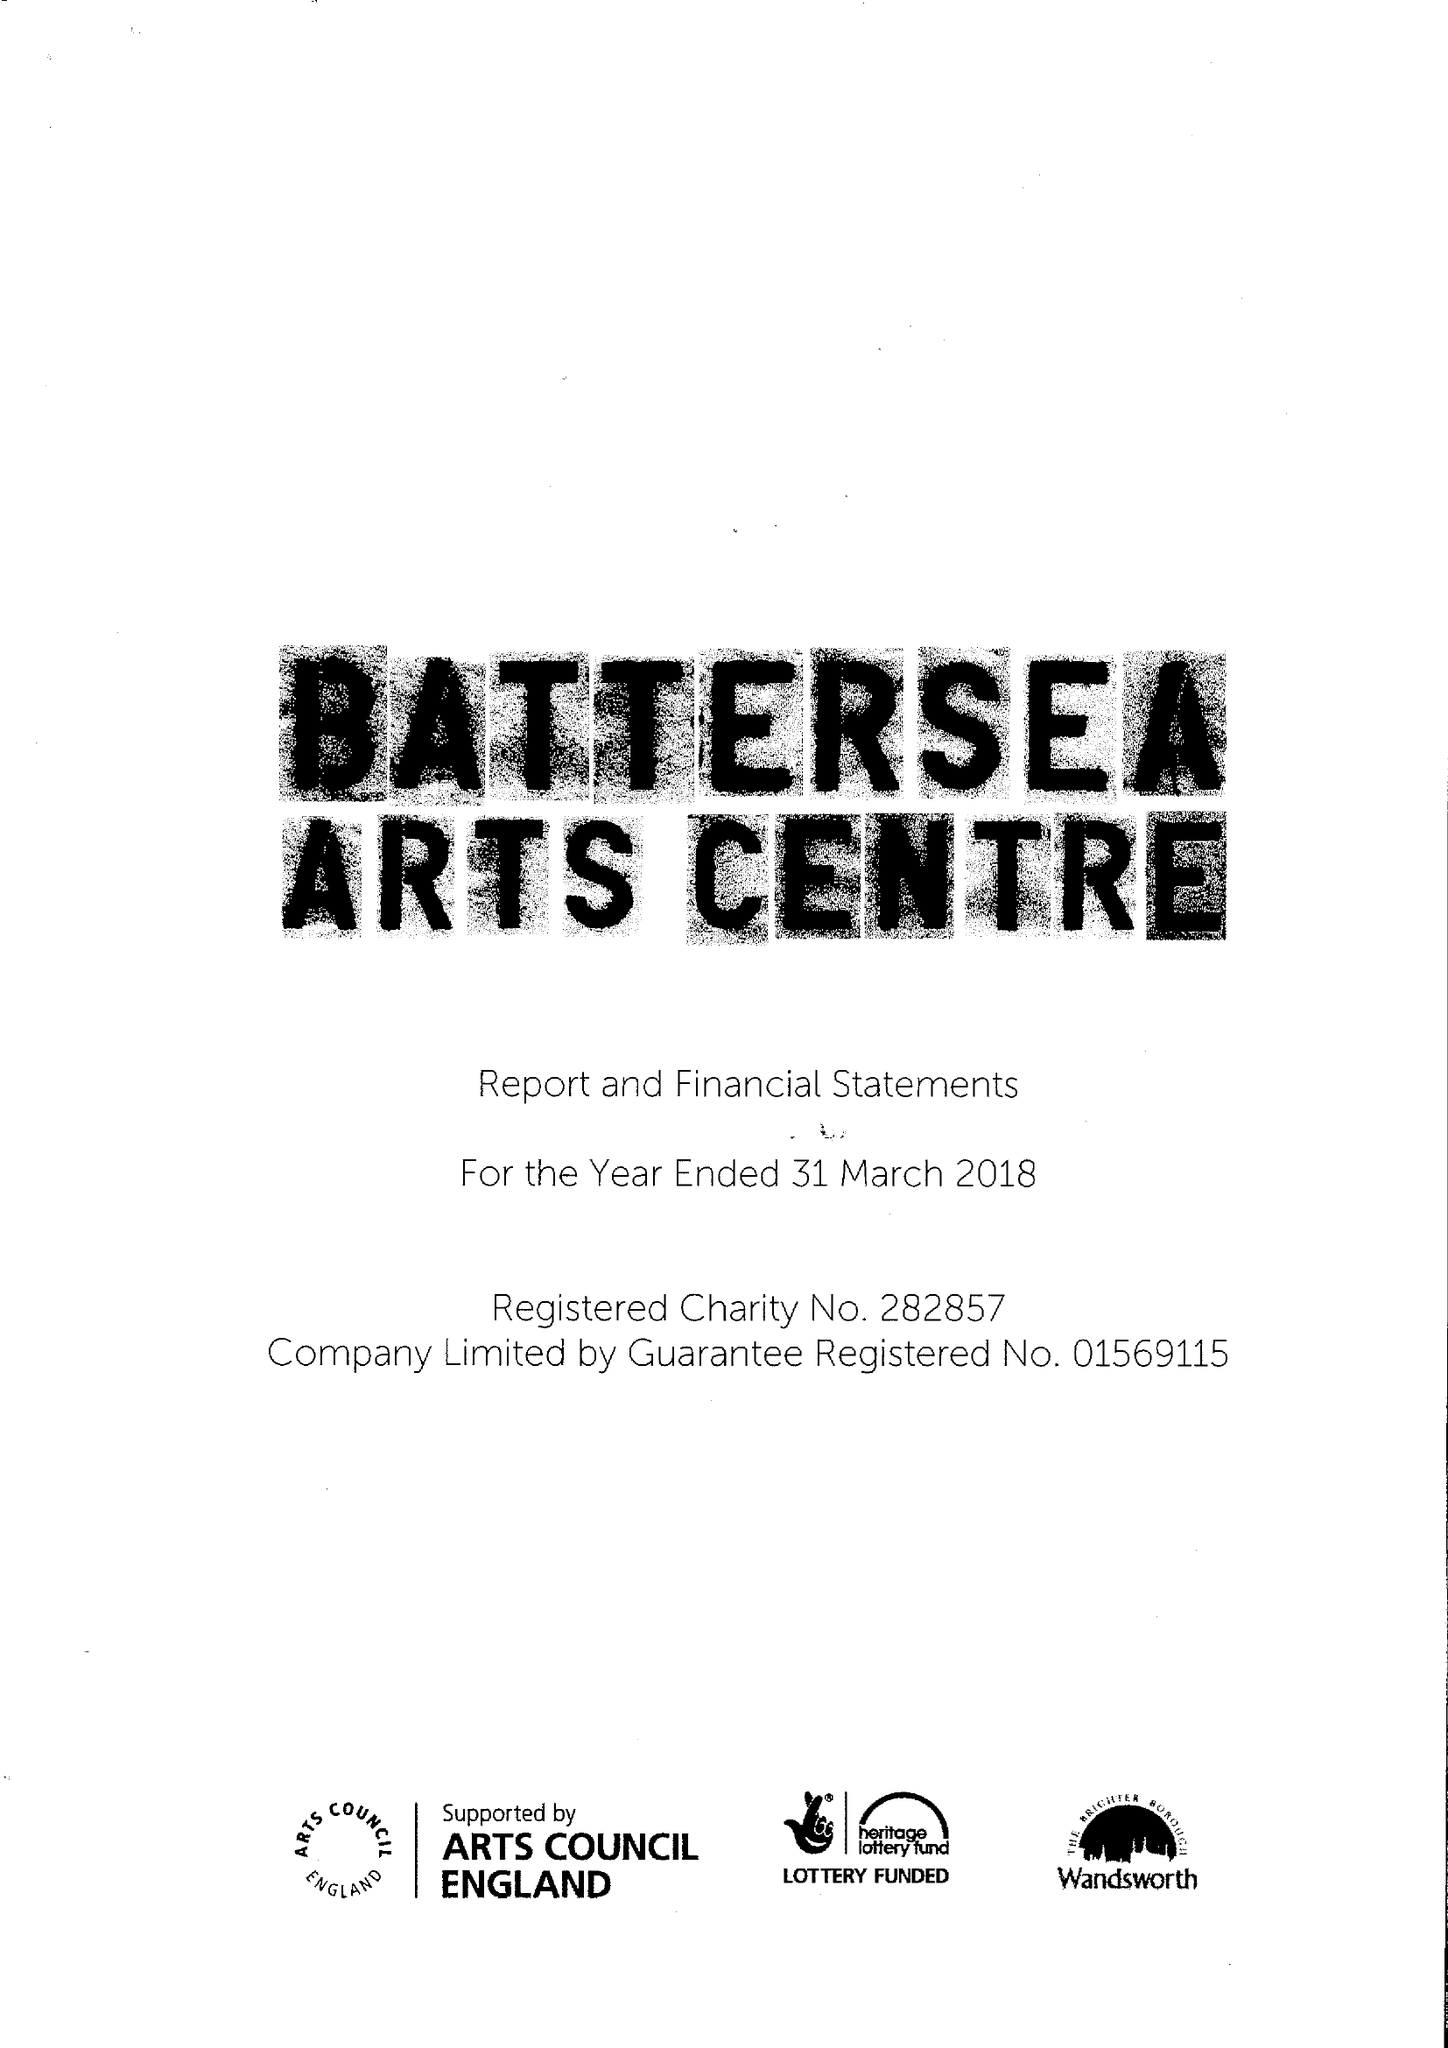What is the value for the charity_name?
Answer the question using a single word or phrase. Battersea Arts Centre 